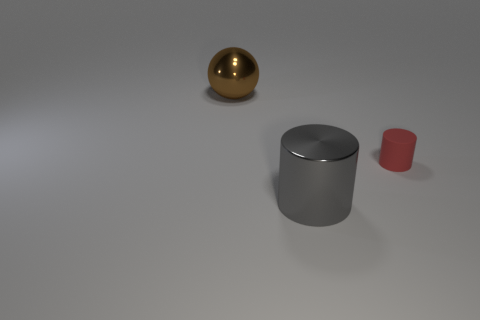Subtract all gray cylinders. How many cylinders are left? 1 Add 3 cyan metal balls. How many objects exist? 6 Add 3 large gray objects. How many large gray objects are left? 4 Add 2 large brown spheres. How many large brown spheres exist? 3 Subtract 0 green spheres. How many objects are left? 3 Subtract all cylinders. How many objects are left? 1 Subtract 1 spheres. How many spheres are left? 0 Subtract all cyan spheres. Subtract all blue cylinders. How many spheres are left? 1 Subtract all cyan cubes. How many gray cylinders are left? 1 Subtract all small brown balls. Subtract all brown things. How many objects are left? 2 